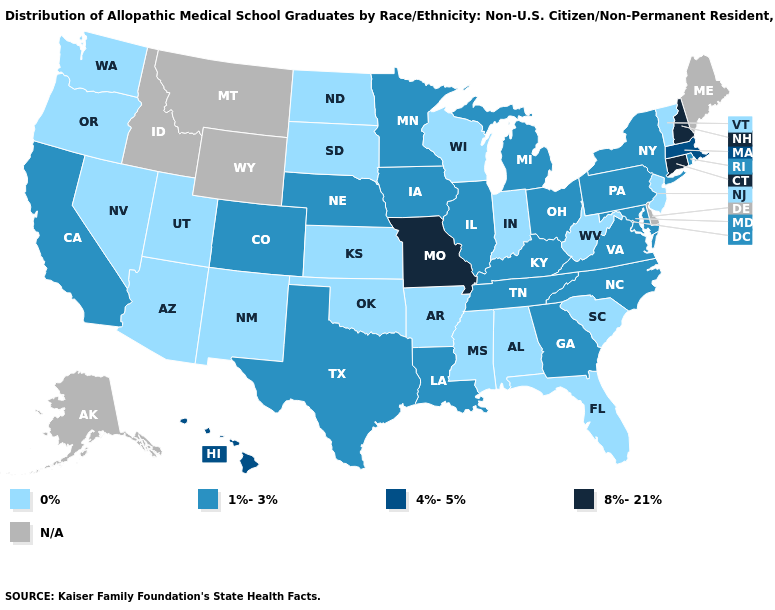Does the map have missing data?
Short answer required. Yes. Which states hav the highest value in the MidWest?
Short answer required. Missouri. Is the legend a continuous bar?
Quick response, please. No. What is the value of California?
Give a very brief answer. 1%-3%. What is the value of Delaware?
Keep it brief. N/A. Which states have the highest value in the USA?
Quick response, please. Connecticut, Missouri, New Hampshire. Is the legend a continuous bar?
Be succinct. No. Name the states that have a value in the range 0%?
Short answer required. Alabama, Arizona, Arkansas, Florida, Indiana, Kansas, Mississippi, Nevada, New Jersey, New Mexico, North Dakota, Oklahoma, Oregon, South Carolina, South Dakota, Utah, Vermont, Washington, West Virginia, Wisconsin. Does the first symbol in the legend represent the smallest category?
Be succinct. Yes. What is the highest value in states that border Idaho?
Keep it brief. 0%. Name the states that have a value in the range 0%?
Short answer required. Alabama, Arizona, Arkansas, Florida, Indiana, Kansas, Mississippi, Nevada, New Jersey, New Mexico, North Dakota, Oklahoma, Oregon, South Carolina, South Dakota, Utah, Vermont, Washington, West Virginia, Wisconsin. What is the lowest value in the Northeast?
Write a very short answer. 0%. Name the states that have a value in the range 4%-5%?
Be succinct. Hawaii, Massachusetts. Name the states that have a value in the range 8%-21%?
Quick response, please. Connecticut, Missouri, New Hampshire. 